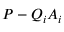Convert formula to latex. <formula><loc_0><loc_0><loc_500><loc_500>P - Q _ { i } A _ { i }</formula> 